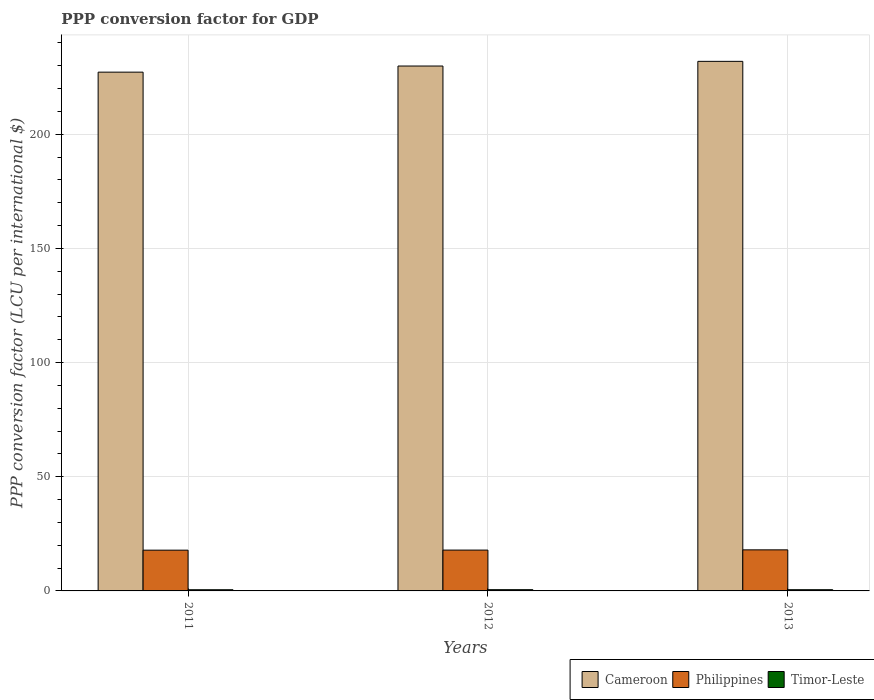How many different coloured bars are there?
Keep it short and to the point. 3. How many groups of bars are there?
Keep it short and to the point. 3. How many bars are there on the 3rd tick from the right?
Give a very brief answer. 3. In how many cases, is the number of bars for a given year not equal to the number of legend labels?
Offer a very short reply. 0. What is the PPP conversion factor for GDP in Timor-Leste in 2012?
Offer a very short reply. 0.54. Across all years, what is the maximum PPP conversion factor for GDP in Cameroon?
Your answer should be compact. 231.94. Across all years, what is the minimum PPP conversion factor for GDP in Cameroon?
Your answer should be compact. 227.21. In which year was the PPP conversion factor for GDP in Timor-Leste minimum?
Your response must be concise. 2011. What is the total PPP conversion factor for GDP in Cameroon in the graph?
Ensure brevity in your answer.  689.05. What is the difference between the PPP conversion factor for GDP in Philippines in 2011 and that in 2012?
Keep it short and to the point. -0.03. What is the difference between the PPP conversion factor for GDP in Timor-Leste in 2012 and the PPP conversion factor for GDP in Cameroon in 2013?
Offer a terse response. -231.39. What is the average PPP conversion factor for GDP in Cameroon per year?
Your answer should be very brief. 229.68. In the year 2013, what is the difference between the PPP conversion factor for GDP in Timor-Leste and PPP conversion factor for GDP in Philippines?
Your response must be concise. -17.46. What is the ratio of the PPP conversion factor for GDP in Philippines in 2012 to that in 2013?
Give a very brief answer. 0.99. Is the PPP conversion factor for GDP in Timor-Leste in 2011 less than that in 2013?
Keep it short and to the point. Yes. What is the difference between the highest and the second highest PPP conversion factor for GDP in Cameroon?
Give a very brief answer. 2.04. What is the difference between the highest and the lowest PPP conversion factor for GDP in Philippines?
Give a very brief answer. 0.14. Is the sum of the PPP conversion factor for GDP in Cameroon in 2012 and 2013 greater than the maximum PPP conversion factor for GDP in Philippines across all years?
Ensure brevity in your answer.  Yes. What does the 2nd bar from the left in 2011 represents?
Provide a short and direct response. Philippines. What does the 3rd bar from the right in 2012 represents?
Provide a short and direct response. Cameroon. How many years are there in the graph?
Ensure brevity in your answer.  3. Are the values on the major ticks of Y-axis written in scientific E-notation?
Offer a very short reply. No. Does the graph contain grids?
Your response must be concise. Yes. Where does the legend appear in the graph?
Ensure brevity in your answer.  Bottom right. What is the title of the graph?
Ensure brevity in your answer.  PPP conversion factor for GDP. What is the label or title of the Y-axis?
Your answer should be compact. PPP conversion factor (LCU per international $). What is the PPP conversion factor (LCU per international $) in Cameroon in 2011?
Offer a very short reply. 227.21. What is the PPP conversion factor (LCU per international $) in Philippines in 2011?
Your response must be concise. 17.85. What is the PPP conversion factor (LCU per international $) of Timor-Leste in 2011?
Your answer should be compact. 0.52. What is the PPP conversion factor (LCU per international $) in Cameroon in 2012?
Keep it short and to the point. 229.9. What is the PPP conversion factor (LCU per international $) in Philippines in 2012?
Your answer should be very brief. 17.88. What is the PPP conversion factor (LCU per international $) in Timor-Leste in 2012?
Offer a terse response. 0.54. What is the PPP conversion factor (LCU per international $) of Cameroon in 2013?
Provide a short and direct response. 231.94. What is the PPP conversion factor (LCU per international $) in Philippines in 2013?
Make the answer very short. 17.99. What is the PPP conversion factor (LCU per international $) in Timor-Leste in 2013?
Provide a succinct answer. 0.53. Across all years, what is the maximum PPP conversion factor (LCU per international $) in Cameroon?
Ensure brevity in your answer.  231.94. Across all years, what is the maximum PPP conversion factor (LCU per international $) in Philippines?
Make the answer very short. 17.99. Across all years, what is the maximum PPP conversion factor (LCU per international $) of Timor-Leste?
Keep it short and to the point. 0.54. Across all years, what is the minimum PPP conversion factor (LCU per international $) of Cameroon?
Keep it short and to the point. 227.21. Across all years, what is the minimum PPP conversion factor (LCU per international $) of Philippines?
Ensure brevity in your answer.  17.85. Across all years, what is the minimum PPP conversion factor (LCU per international $) of Timor-Leste?
Your answer should be very brief. 0.52. What is the total PPP conversion factor (LCU per international $) of Cameroon in the graph?
Offer a terse response. 689.05. What is the total PPP conversion factor (LCU per international $) in Philippines in the graph?
Give a very brief answer. 53.73. What is the total PPP conversion factor (LCU per international $) of Timor-Leste in the graph?
Keep it short and to the point. 1.59. What is the difference between the PPP conversion factor (LCU per international $) of Cameroon in 2011 and that in 2012?
Offer a terse response. -2.68. What is the difference between the PPP conversion factor (LCU per international $) in Philippines in 2011 and that in 2012?
Offer a very short reply. -0.03. What is the difference between the PPP conversion factor (LCU per international $) of Timor-Leste in 2011 and that in 2012?
Give a very brief answer. -0.03. What is the difference between the PPP conversion factor (LCU per international $) in Cameroon in 2011 and that in 2013?
Offer a very short reply. -4.73. What is the difference between the PPP conversion factor (LCU per international $) in Philippines in 2011 and that in 2013?
Your answer should be very brief. -0.14. What is the difference between the PPP conversion factor (LCU per international $) in Timor-Leste in 2011 and that in 2013?
Offer a very short reply. -0.01. What is the difference between the PPP conversion factor (LCU per international $) in Cameroon in 2012 and that in 2013?
Provide a short and direct response. -2.04. What is the difference between the PPP conversion factor (LCU per international $) in Philippines in 2012 and that in 2013?
Your answer should be very brief. -0.11. What is the difference between the PPP conversion factor (LCU per international $) in Timor-Leste in 2012 and that in 2013?
Provide a short and direct response. 0.01. What is the difference between the PPP conversion factor (LCU per international $) in Cameroon in 2011 and the PPP conversion factor (LCU per international $) in Philippines in 2012?
Your answer should be compact. 209.33. What is the difference between the PPP conversion factor (LCU per international $) in Cameroon in 2011 and the PPP conversion factor (LCU per international $) in Timor-Leste in 2012?
Keep it short and to the point. 226.67. What is the difference between the PPP conversion factor (LCU per international $) of Philippines in 2011 and the PPP conversion factor (LCU per international $) of Timor-Leste in 2012?
Provide a succinct answer. 17.31. What is the difference between the PPP conversion factor (LCU per international $) of Cameroon in 2011 and the PPP conversion factor (LCU per international $) of Philippines in 2013?
Your answer should be compact. 209.22. What is the difference between the PPP conversion factor (LCU per international $) in Cameroon in 2011 and the PPP conversion factor (LCU per international $) in Timor-Leste in 2013?
Keep it short and to the point. 226.68. What is the difference between the PPP conversion factor (LCU per international $) in Philippines in 2011 and the PPP conversion factor (LCU per international $) in Timor-Leste in 2013?
Offer a terse response. 17.32. What is the difference between the PPP conversion factor (LCU per international $) of Cameroon in 2012 and the PPP conversion factor (LCU per international $) of Philippines in 2013?
Your answer should be compact. 211.91. What is the difference between the PPP conversion factor (LCU per international $) of Cameroon in 2012 and the PPP conversion factor (LCU per international $) of Timor-Leste in 2013?
Ensure brevity in your answer.  229.37. What is the difference between the PPP conversion factor (LCU per international $) of Philippines in 2012 and the PPP conversion factor (LCU per international $) of Timor-Leste in 2013?
Give a very brief answer. 17.35. What is the average PPP conversion factor (LCU per international $) of Cameroon per year?
Offer a very short reply. 229.68. What is the average PPP conversion factor (LCU per international $) in Philippines per year?
Offer a terse response. 17.91. What is the average PPP conversion factor (LCU per international $) of Timor-Leste per year?
Make the answer very short. 0.53. In the year 2011, what is the difference between the PPP conversion factor (LCU per international $) of Cameroon and PPP conversion factor (LCU per international $) of Philippines?
Your response must be concise. 209.36. In the year 2011, what is the difference between the PPP conversion factor (LCU per international $) in Cameroon and PPP conversion factor (LCU per international $) in Timor-Leste?
Keep it short and to the point. 226.69. In the year 2011, what is the difference between the PPP conversion factor (LCU per international $) of Philippines and PPP conversion factor (LCU per international $) of Timor-Leste?
Ensure brevity in your answer.  17.34. In the year 2012, what is the difference between the PPP conversion factor (LCU per international $) of Cameroon and PPP conversion factor (LCU per international $) of Philippines?
Offer a terse response. 212.01. In the year 2012, what is the difference between the PPP conversion factor (LCU per international $) of Cameroon and PPP conversion factor (LCU per international $) of Timor-Leste?
Provide a succinct answer. 229.35. In the year 2012, what is the difference between the PPP conversion factor (LCU per international $) of Philippines and PPP conversion factor (LCU per international $) of Timor-Leste?
Ensure brevity in your answer.  17.34. In the year 2013, what is the difference between the PPP conversion factor (LCU per international $) of Cameroon and PPP conversion factor (LCU per international $) of Philippines?
Give a very brief answer. 213.95. In the year 2013, what is the difference between the PPP conversion factor (LCU per international $) in Cameroon and PPP conversion factor (LCU per international $) in Timor-Leste?
Make the answer very short. 231.41. In the year 2013, what is the difference between the PPP conversion factor (LCU per international $) in Philippines and PPP conversion factor (LCU per international $) in Timor-Leste?
Offer a terse response. 17.46. What is the ratio of the PPP conversion factor (LCU per international $) of Cameroon in 2011 to that in 2012?
Keep it short and to the point. 0.99. What is the ratio of the PPP conversion factor (LCU per international $) in Philippines in 2011 to that in 2012?
Your answer should be compact. 1. What is the ratio of the PPP conversion factor (LCU per international $) of Timor-Leste in 2011 to that in 2012?
Offer a terse response. 0.95. What is the ratio of the PPP conversion factor (LCU per international $) of Cameroon in 2011 to that in 2013?
Keep it short and to the point. 0.98. What is the ratio of the PPP conversion factor (LCU per international $) of Timor-Leste in 2011 to that in 2013?
Ensure brevity in your answer.  0.97. What is the ratio of the PPP conversion factor (LCU per international $) in Timor-Leste in 2012 to that in 2013?
Provide a short and direct response. 1.02. What is the difference between the highest and the second highest PPP conversion factor (LCU per international $) of Cameroon?
Provide a succinct answer. 2.04. What is the difference between the highest and the second highest PPP conversion factor (LCU per international $) of Philippines?
Your answer should be compact. 0.11. What is the difference between the highest and the second highest PPP conversion factor (LCU per international $) in Timor-Leste?
Ensure brevity in your answer.  0.01. What is the difference between the highest and the lowest PPP conversion factor (LCU per international $) in Cameroon?
Your response must be concise. 4.73. What is the difference between the highest and the lowest PPP conversion factor (LCU per international $) of Philippines?
Your answer should be very brief. 0.14. What is the difference between the highest and the lowest PPP conversion factor (LCU per international $) of Timor-Leste?
Make the answer very short. 0.03. 